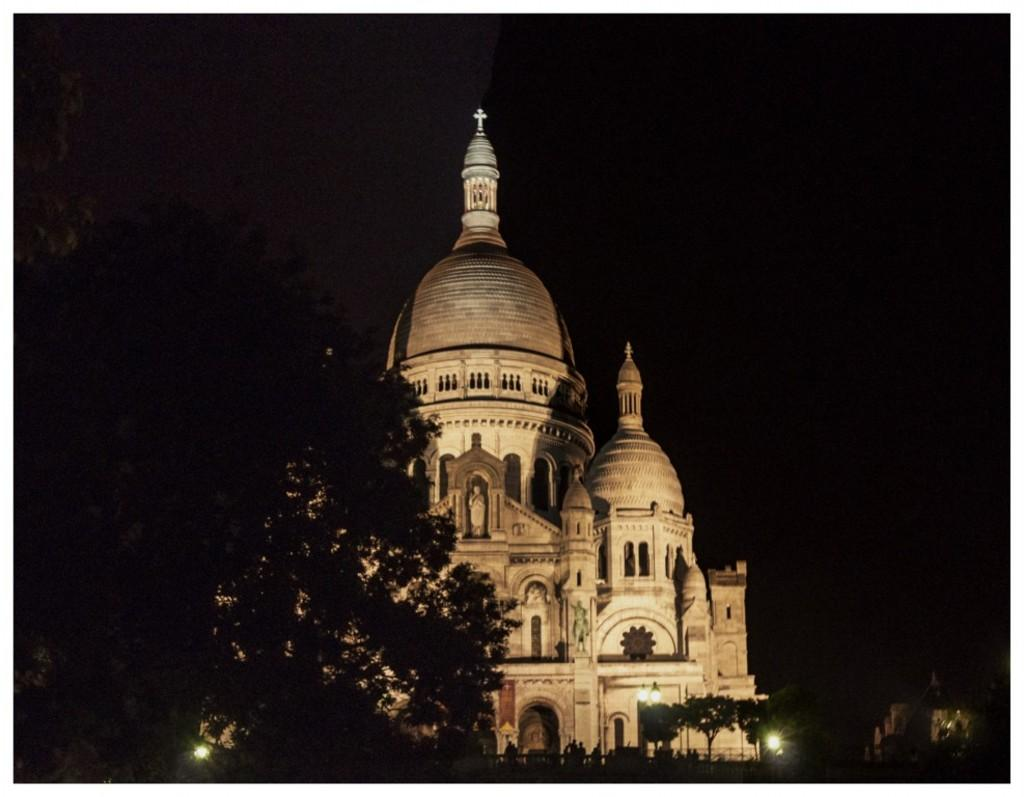What type of building is in the image? There is a church in the image. What other natural elements can be seen in the image? There are trees in the image. What type of illumination is present in the image? There are lights in the image. Are there any people in the image? Yes, there are people in the image. What is the color of the background in the image? The background of the image is black. Can you see anyone wearing a scarf in the image? There is no mention of a scarf in the image, so it cannot be determined if anyone is wearing one. What time does the clock in the image show? There is no clock present in the image. 